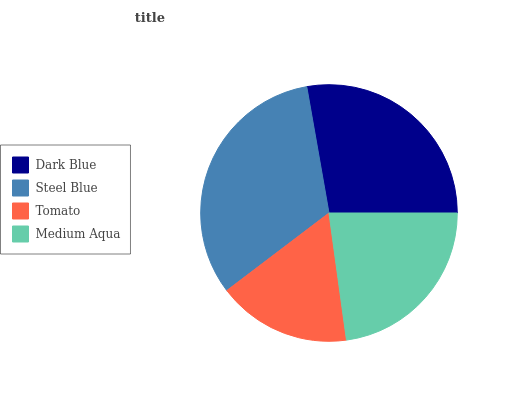Is Tomato the minimum?
Answer yes or no. Yes. Is Steel Blue the maximum?
Answer yes or no. Yes. Is Steel Blue the minimum?
Answer yes or no. No. Is Tomato the maximum?
Answer yes or no. No. Is Steel Blue greater than Tomato?
Answer yes or no. Yes. Is Tomato less than Steel Blue?
Answer yes or no. Yes. Is Tomato greater than Steel Blue?
Answer yes or no. No. Is Steel Blue less than Tomato?
Answer yes or no. No. Is Dark Blue the high median?
Answer yes or no. Yes. Is Medium Aqua the low median?
Answer yes or no. Yes. Is Tomato the high median?
Answer yes or no. No. Is Tomato the low median?
Answer yes or no. No. 